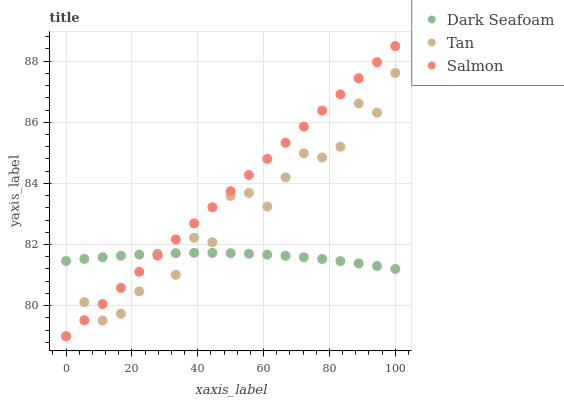Does Dark Seafoam have the minimum area under the curve?
Answer yes or no. Yes. Does Salmon have the maximum area under the curve?
Answer yes or no. Yes. Does Tan have the minimum area under the curve?
Answer yes or no. No. Does Tan have the maximum area under the curve?
Answer yes or no. No. Is Salmon the smoothest?
Answer yes or no. Yes. Is Tan the roughest?
Answer yes or no. Yes. Is Tan the smoothest?
Answer yes or no. No. Is Salmon the roughest?
Answer yes or no. No. Does Salmon have the lowest value?
Answer yes or no. Yes. Does Salmon have the highest value?
Answer yes or no. Yes. Does Tan have the highest value?
Answer yes or no. No. Does Dark Seafoam intersect Salmon?
Answer yes or no. Yes. Is Dark Seafoam less than Salmon?
Answer yes or no. No. Is Dark Seafoam greater than Salmon?
Answer yes or no. No. 